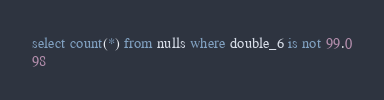Convert code to text. <code><loc_0><loc_0><loc_500><loc_500><_SQL_>select count(*) from nulls where double_6 is not 99.0
98
</code> 